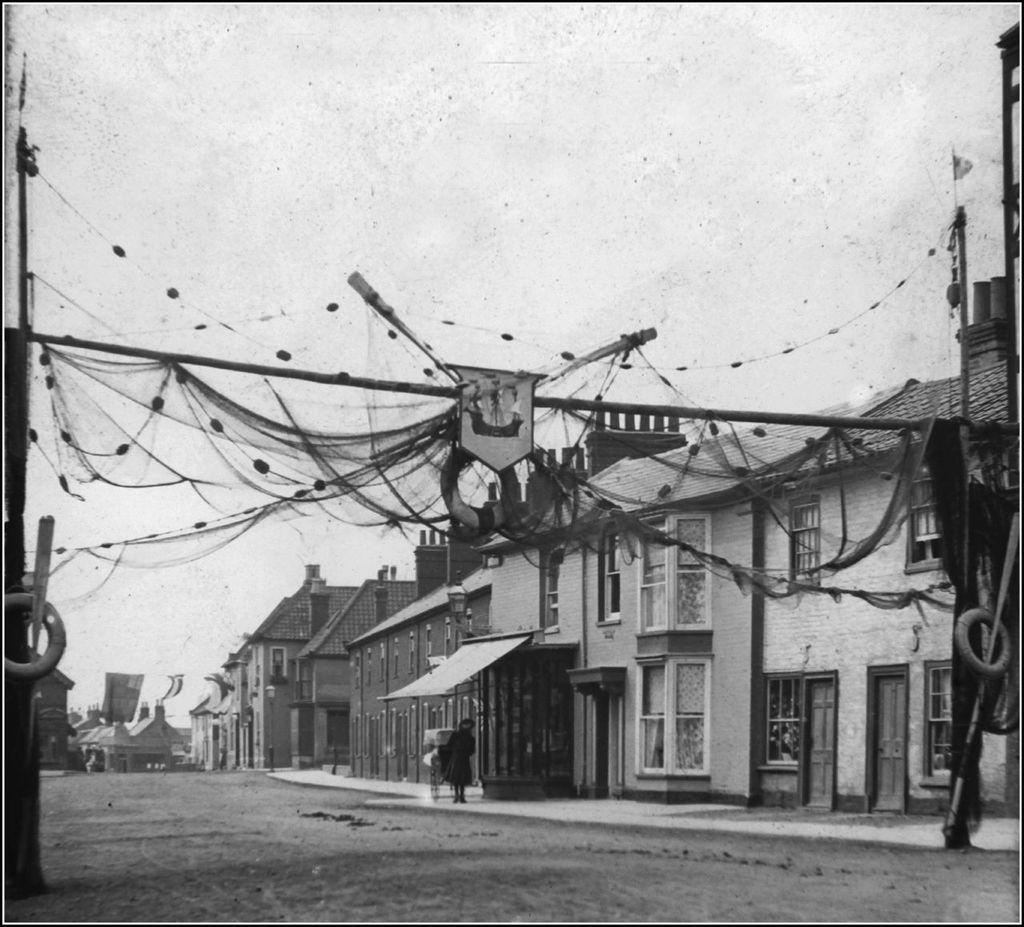In one or two sentences, can you explain what this image depicts? In this image in the center there is a person standing and there are buildings. In the front on the top there is a cloth hanging and the sky is cloudy. 